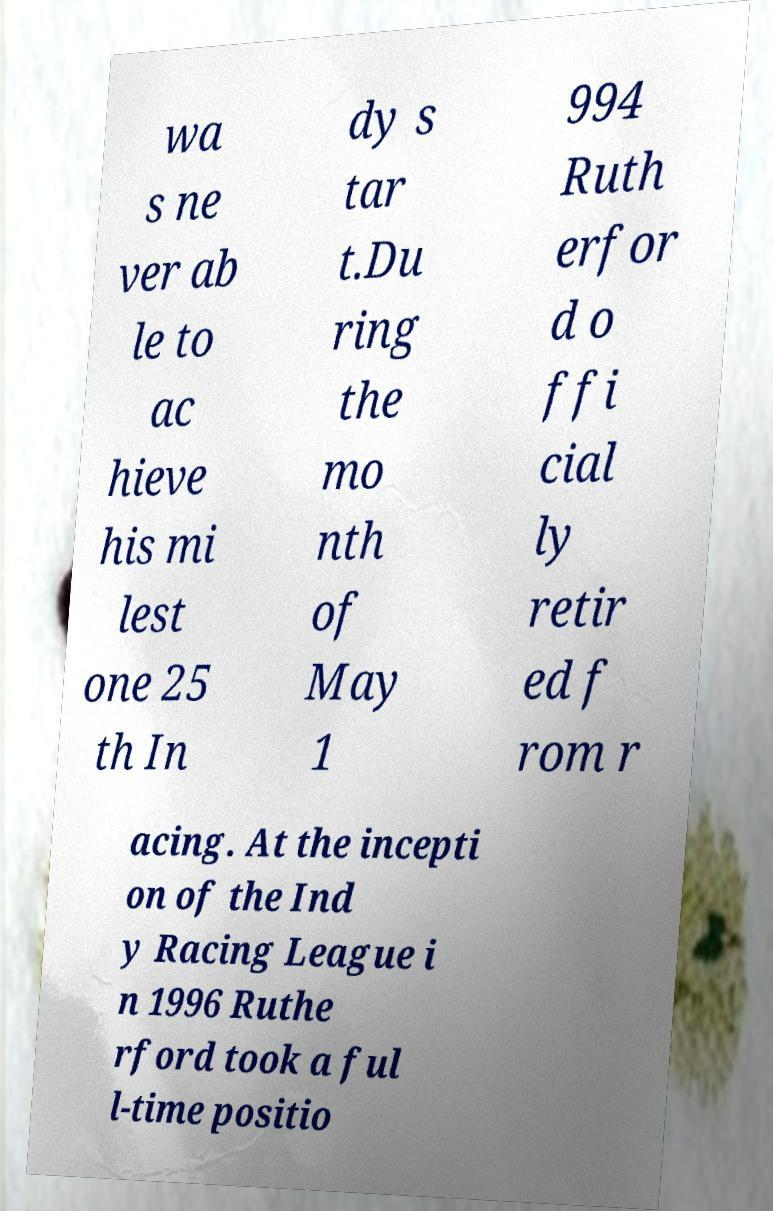For documentation purposes, I need the text within this image transcribed. Could you provide that? wa s ne ver ab le to ac hieve his mi lest one 25 th In dy s tar t.Du ring the mo nth of May 1 994 Ruth erfor d o ffi cial ly retir ed f rom r acing. At the incepti on of the Ind y Racing League i n 1996 Ruthe rford took a ful l-time positio 